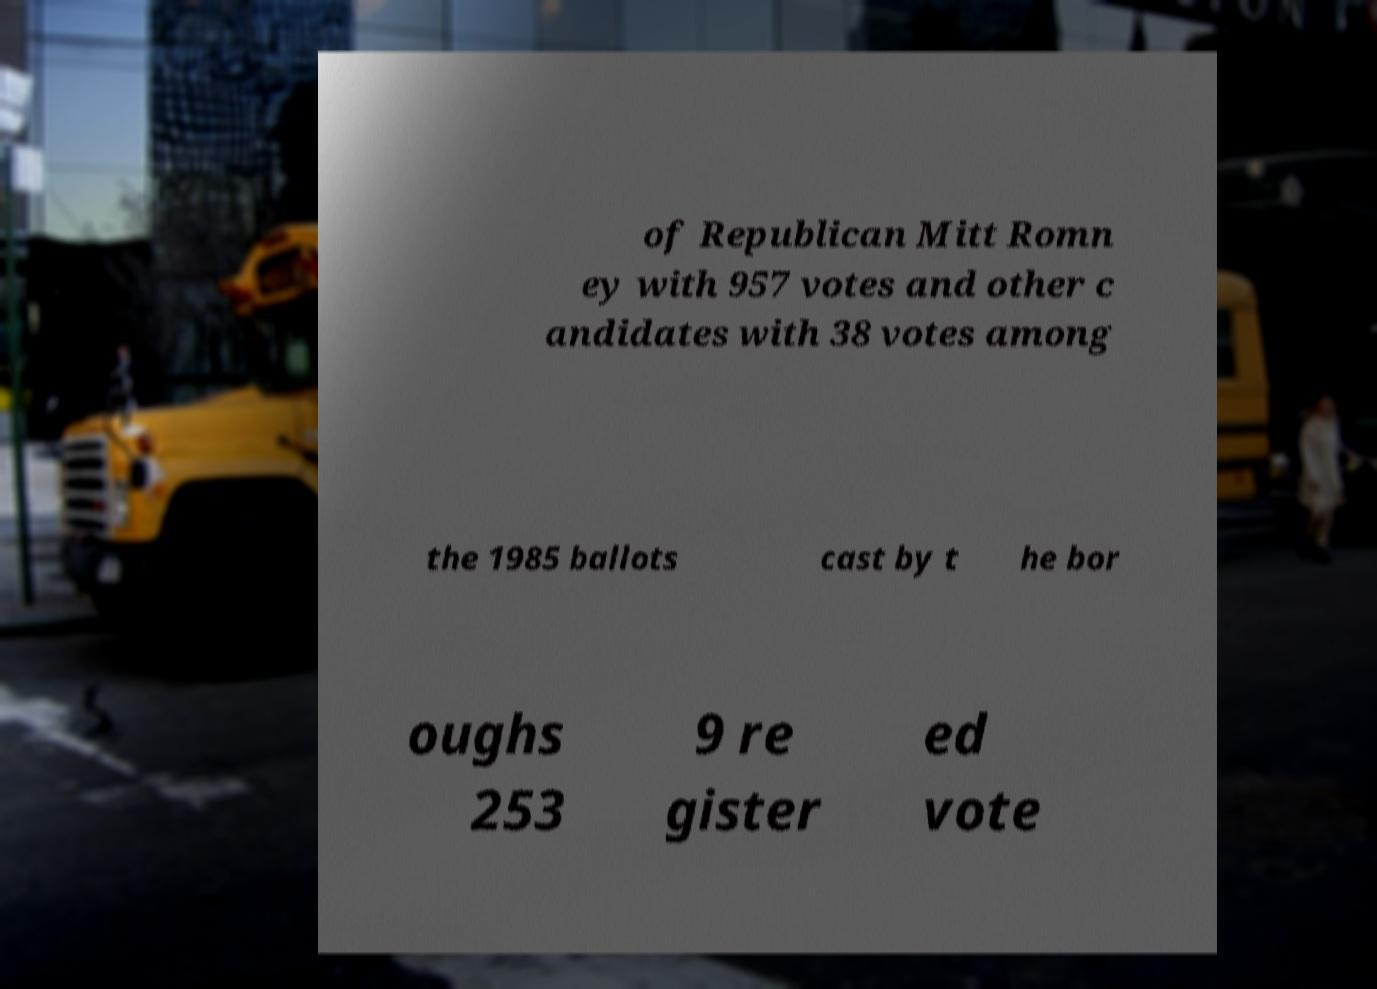For documentation purposes, I need the text within this image transcribed. Could you provide that? of Republican Mitt Romn ey with 957 votes and other c andidates with 38 votes among the 1985 ballots cast by t he bor oughs 253 9 re gister ed vote 